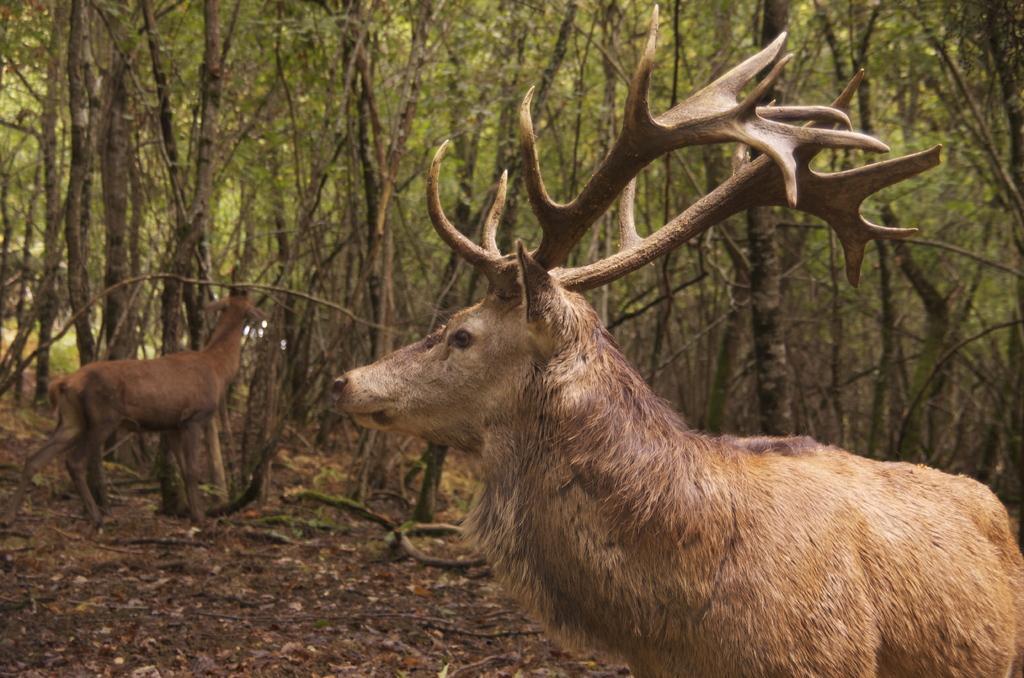Please provide a concise description of this image. In this image I can see 2 deer and there are trees at the back. 